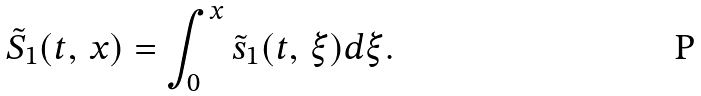Convert formula to latex. <formula><loc_0><loc_0><loc_500><loc_500>\tilde { S } _ { 1 } ( t , \, x ) = \int _ { 0 } ^ { x } \tilde { s } _ { 1 } ( t , \, \xi ) d \xi .</formula> 